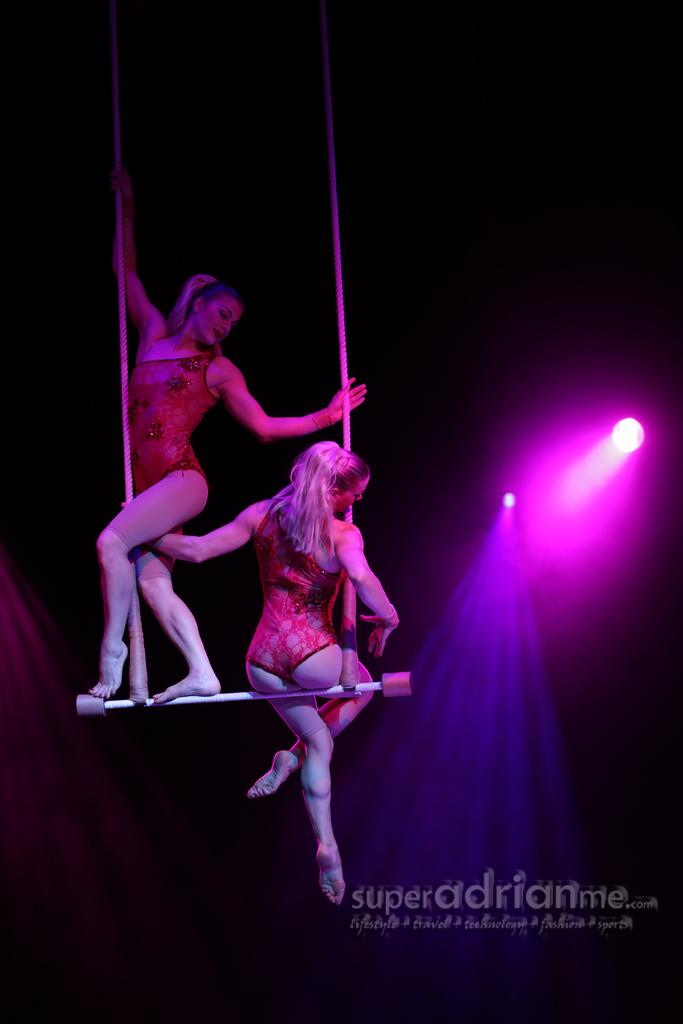How many people are in the image? There are two persons in the image. What are the persons doing in the image? The persons are doing aerial dance with poles. What can be seen in the background or surrounding the persons? There are lights visible in the image. Is there any additional information about the image itself? Yes, there is a watermark on the image. What is the reaction of the mailbox to the aerial dance in the image? There is no mailbox present in the image, so it cannot react to the aerial dance. 